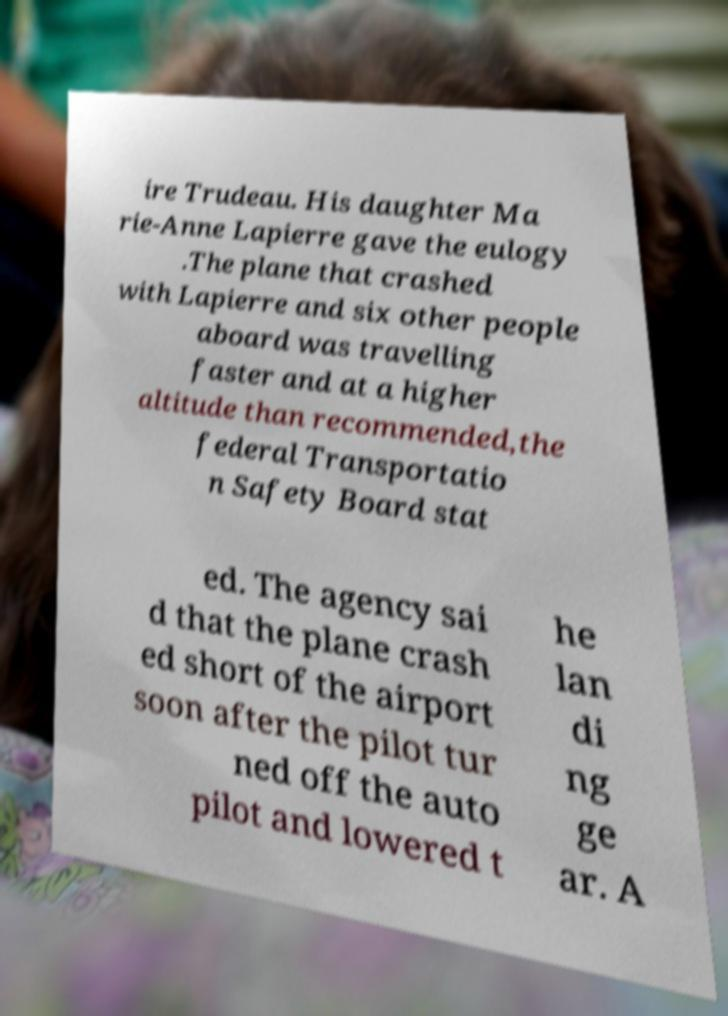For documentation purposes, I need the text within this image transcribed. Could you provide that? ire Trudeau. His daughter Ma rie-Anne Lapierre gave the eulogy .The plane that crashed with Lapierre and six other people aboard was travelling faster and at a higher altitude than recommended,the federal Transportatio n Safety Board stat ed. The agency sai d that the plane crash ed short of the airport soon after the pilot tur ned off the auto pilot and lowered t he lan di ng ge ar. A 